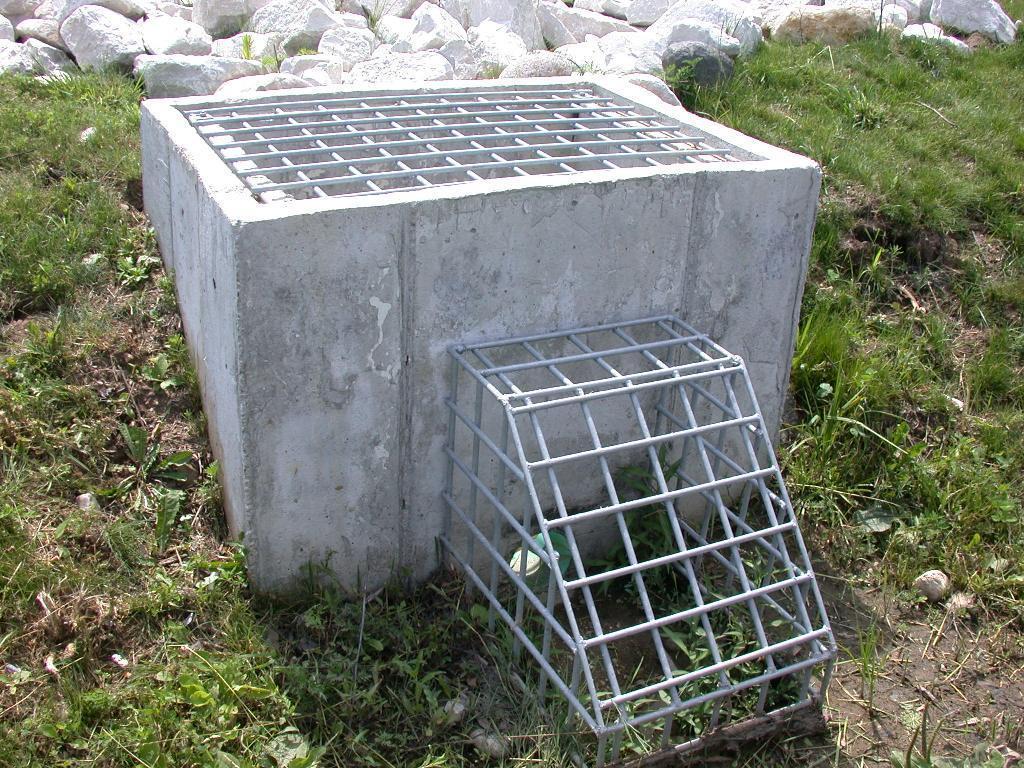Could you give a brief overview of what you see in this image? In the foreground of this image, there is a well like structure having rods on it. Around it, there are grass and rocks. 